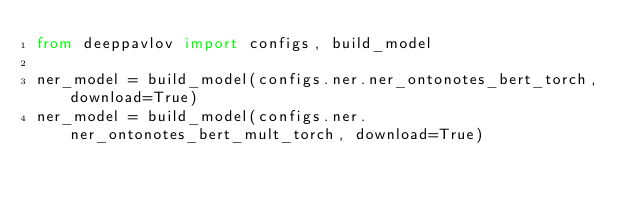<code> <loc_0><loc_0><loc_500><loc_500><_Python_>from deeppavlov import configs, build_model

ner_model = build_model(configs.ner.ner_ontonotes_bert_torch, download=True)
ner_model = build_model(configs.ner.ner_ontonotes_bert_mult_torch, download=True)
</code> 